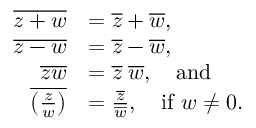Convert formula to latex. <formula><loc_0><loc_0><loc_500><loc_500>{ \begin{array} { r l } { { \overline { z + w } } } & { = { \overline { z } } + { \overline { w } } , } \\ { { \overline { z - w } } } & { = { \overline { z } } - { \overline { w } } , } \\ { { \overline { z w } } } & { = { \overline { z } } \, { \overline { w } } , \quad a n d } \\ { { \overline { { \left ( { \frac { z } { w } } \right ) } } } } & { = { \frac { \overline { z } } { \overline { w } } } , \quad i f w \neq 0 . } \end{array} }</formula> 